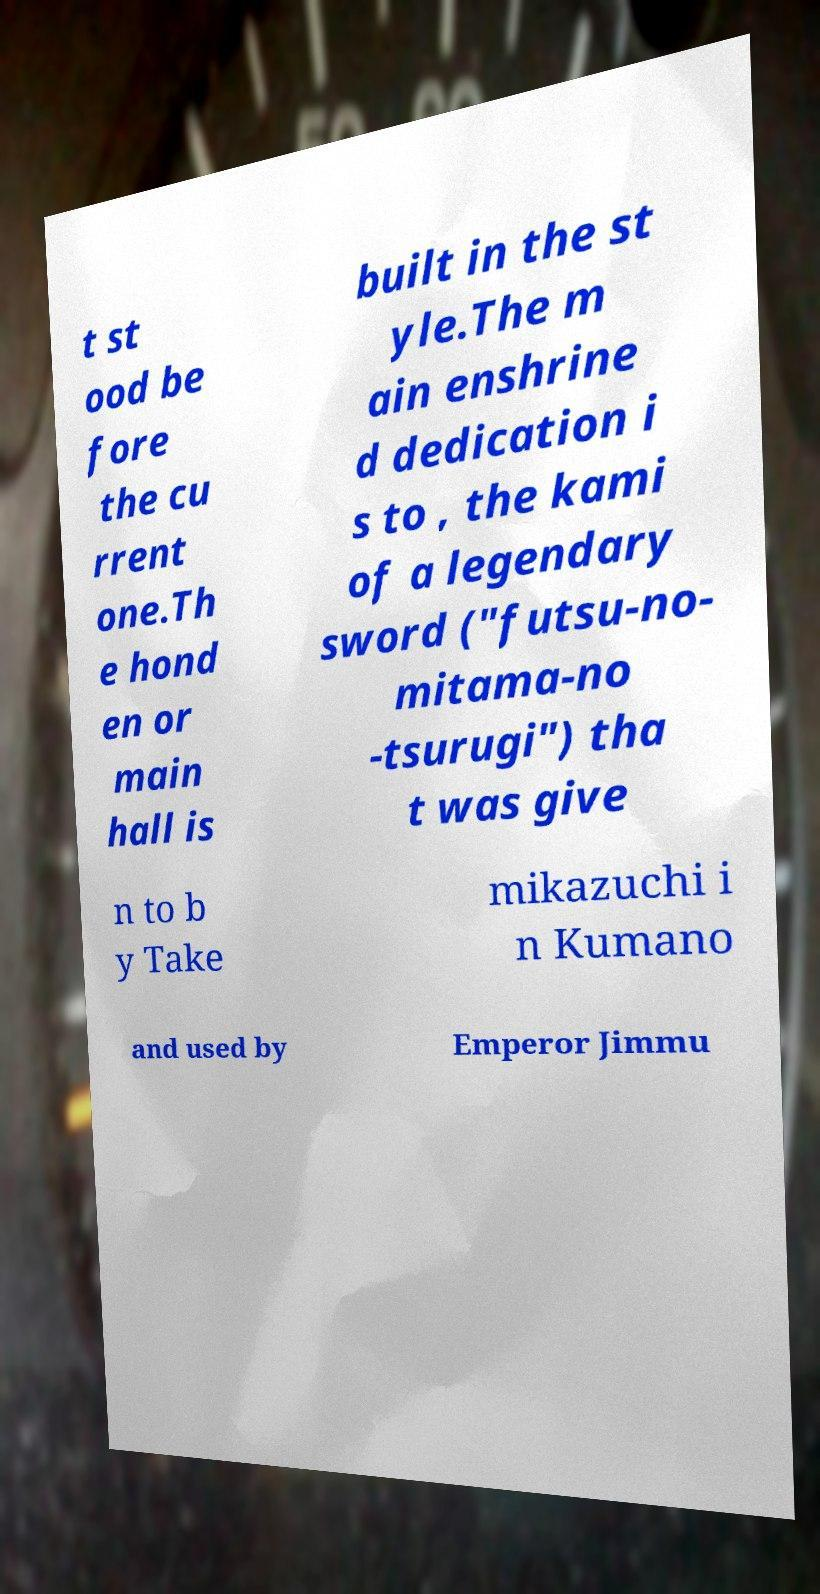Please read and relay the text visible in this image. What does it say? t st ood be fore the cu rrent one.Th e hond en or main hall is built in the st yle.The m ain enshrine d dedication i s to , the kami of a legendary sword ("futsu-no- mitama-no -tsurugi") tha t was give n to b y Take mikazuchi i n Kumano and used by Emperor Jimmu 